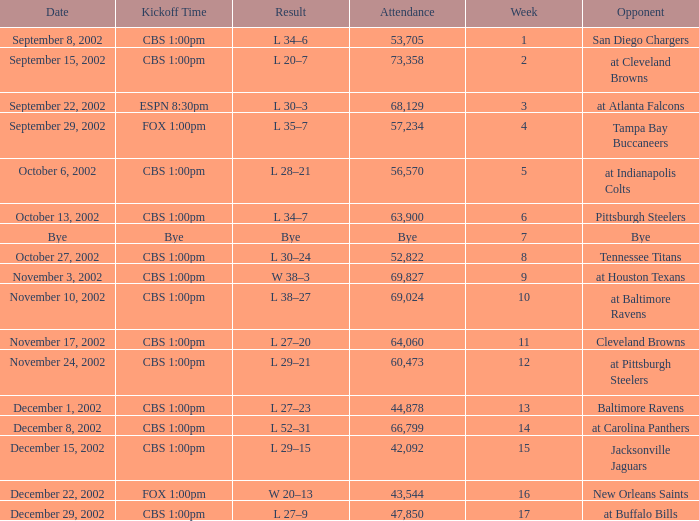How many people attended the game with a kickoff time of cbs 1:00pm, in a week earlier than 8, on September 15, 2002? 73358.0. 